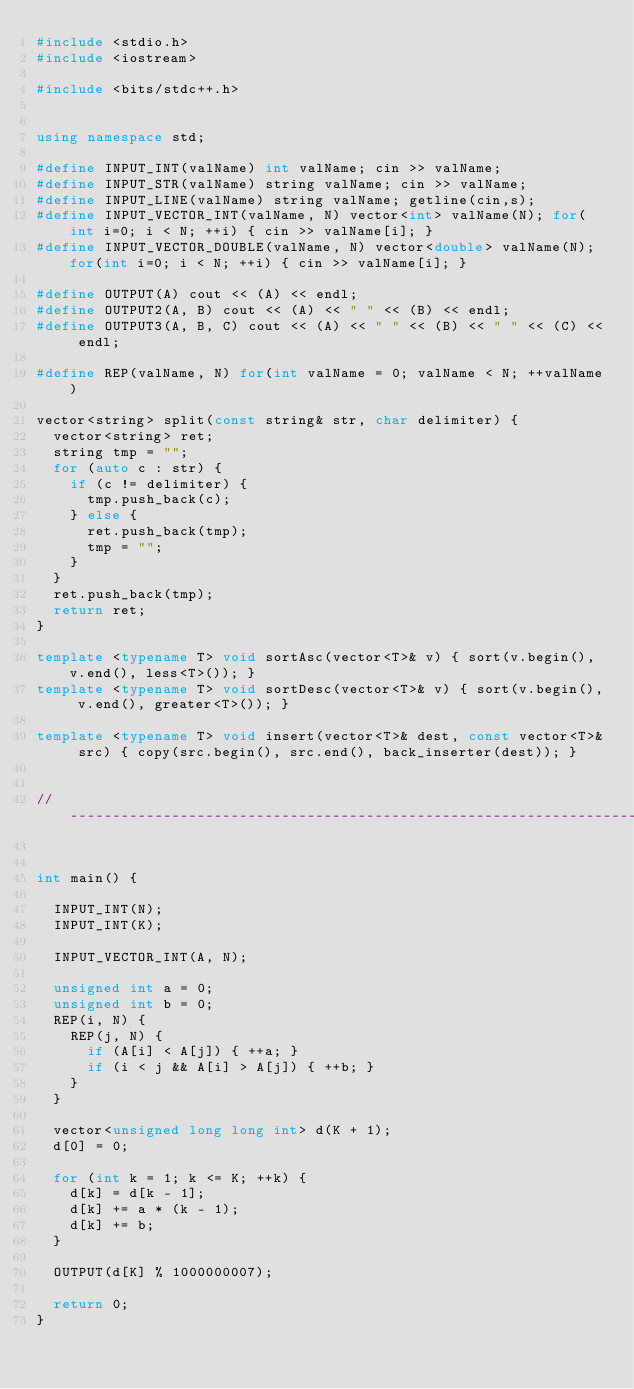Convert code to text. <code><loc_0><loc_0><loc_500><loc_500><_C++_>#include <stdio.h>
#include <iostream>

#include <bits/stdc++.h>


using namespace std;

#define INPUT_INT(valName) int valName; cin >> valName;
#define INPUT_STR(valName) string valName; cin >> valName;
#define INPUT_LINE(valName) string valName; getline(cin,s);
#define INPUT_VECTOR_INT(valName, N) vector<int> valName(N); for(int i=0; i < N; ++i) { cin >> valName[i]; }
#define INPUT_VECTOR_DOUBLE(valName, N) vector<double> valName(N); for(int i=0; i < N; ++i) { cin >> valName[i]; }

#define OUTPUT(A) cout << (A) << endl;
#define OUTPUT2(A, B) cout << (A) << " " << (B) << endl;
#define OUTPUT3(A, B, C) cout << (A) << " " << (B) << " " << (C) << endl;

#define REP(valName, N) for(int valName = 0; valName < N; ++valName)

vector<string> split(const string& str, char delimiter) {
	vector<string> ret;
	string tmp = "";
	for (auto c : str) {
		if (c != delimiter) {
			tmp.push_back(c);
		} else {
			ret.push_back(tmp);
			tmp = "";
		}
	}
	ret.push_back(tmp);
	return ret;
}

template <typename T> void sortAsc(vector<T>& v) { sort(v.begin(), v.end(), less<T>()); }
template <typename T> void sortDesc(vector<T>& v) { sort(v.begin(), v.end(), greater<T>()); }

template <typename T> void insert(vector<T>& dest, const vector<T>& src) { copy(src.begin(), src.end(), back_inserter(dest)); }


//------------------------------------------------------------------------------------------------------------------------------


int main() {

	INPUT_INT(N);
	INPUT_INT(K);

	INPUT_VECTOR_INT(A, N);

	unsigned int a = 0;
	unsigned int b = 0;
	REP(i, N) {
		REP(j, N) {
			if (A[i] < A[j]) { ++a; }
			if (i < j && A[i] > A[j]) { ++b; }
		}
	}

	vector<unsigned long long int> d(K + 1);
	d[0] = 0;

	for (int k = 1; k <= K; ++k) {
		d[k] = d[k - 1];
		d[k] += a * (k - 1);
		d[k] += b;
	}

	OUTPUT(d[K] % 1000000007);

	return 0;
}</code> 